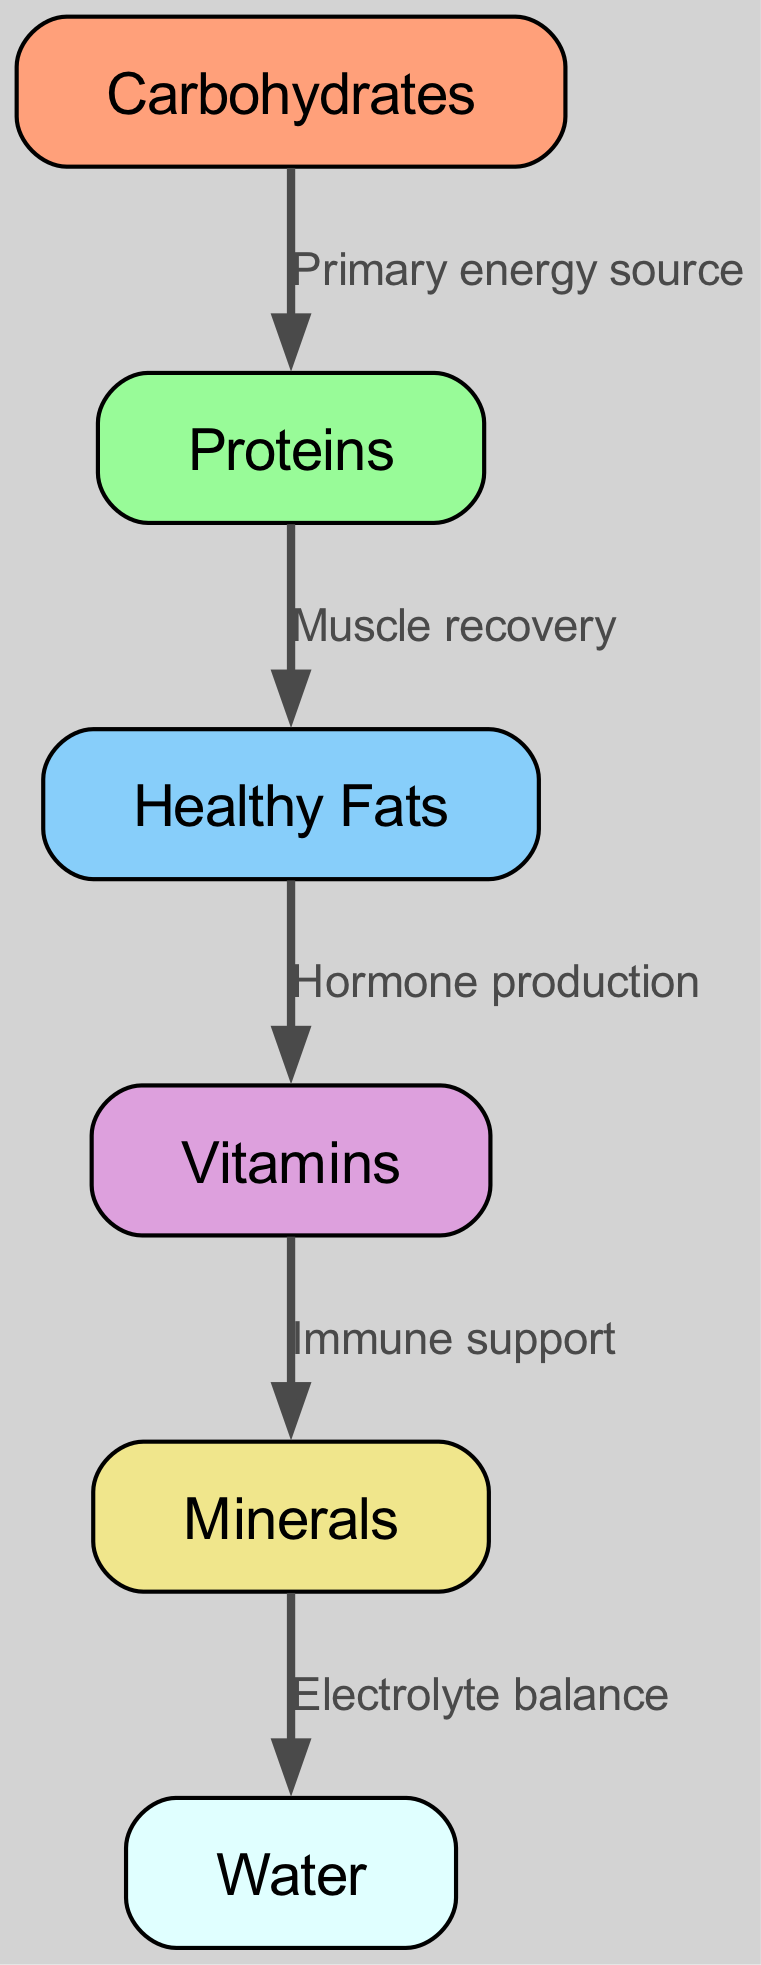What is the primary energy source in an athlete's diet? The diagram indicates that carbohydrates are connected to proteins with the label "Primary energy source," which signifies that carbohydrates are the starting point for energy in the diet.
Answer: Carbohydrates How many nodes are in this food chain diagram? Counting the nodes listed in the diagram, we find there are a total of six distinct nodes including carbohydrates, proteins, healthy fats, vitamins, minerals, and water.
Answer: Six What is the relationship between healthy fats and vitamins? According to the diagram, there is a directed edge from healthy fats to vitamins, labeled "Hormone production," indicating that healthy fats contribute to the production of hormones that vitamins are a part of.
Answer: Hormone production What do vitamins support according to the diagram? The directed edge shows a flow from vitamins to minerals with the label "Immune support." This means vitamins play a role in supporting the immune system, which minerals help strengthen.
Answer: Immune support What element in the food chain helps maintain electrolyte balance? The diagram illustrates that minerals are connected to water via the edge labeled "Electrolyte balance," indicating that minerals help to maintain the body's electrolyte balance, which is crucial for hydration.
Answer: Water 